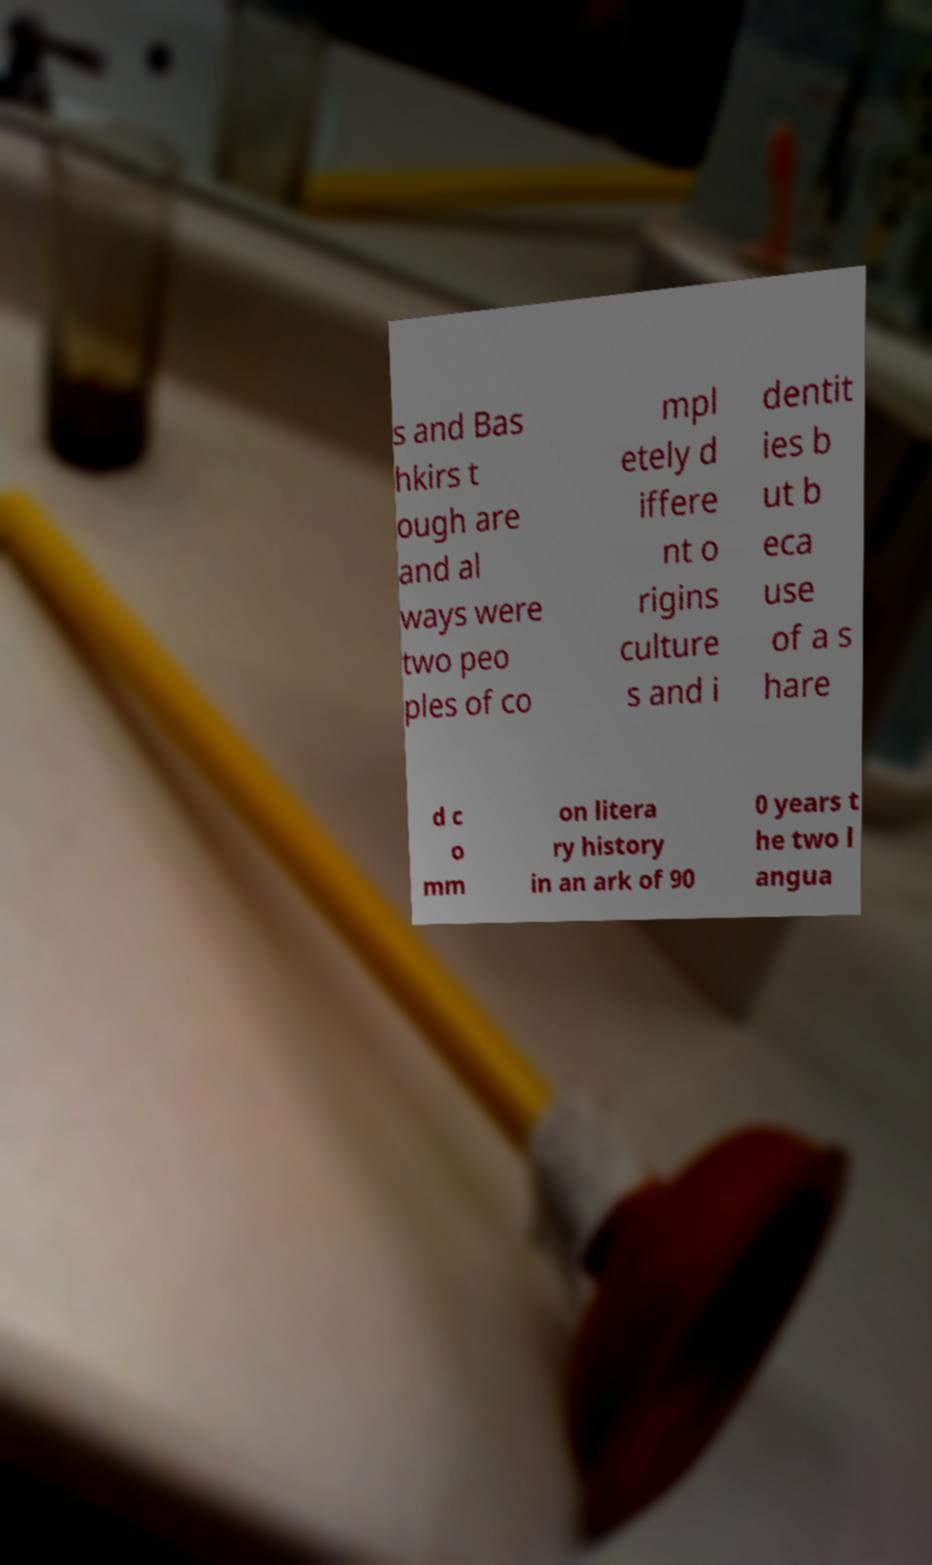What messages or text are displayed in this image? I need them in a readable, typed format. s and Bas hkirs t ough are and al ways were two peo ples of co mpl etely d iffere nt o rigins culture s and i dentit ies b ut b eca use of a s hare d c o mm on litera ry history in an ark of 90 0 years t he two l angua 